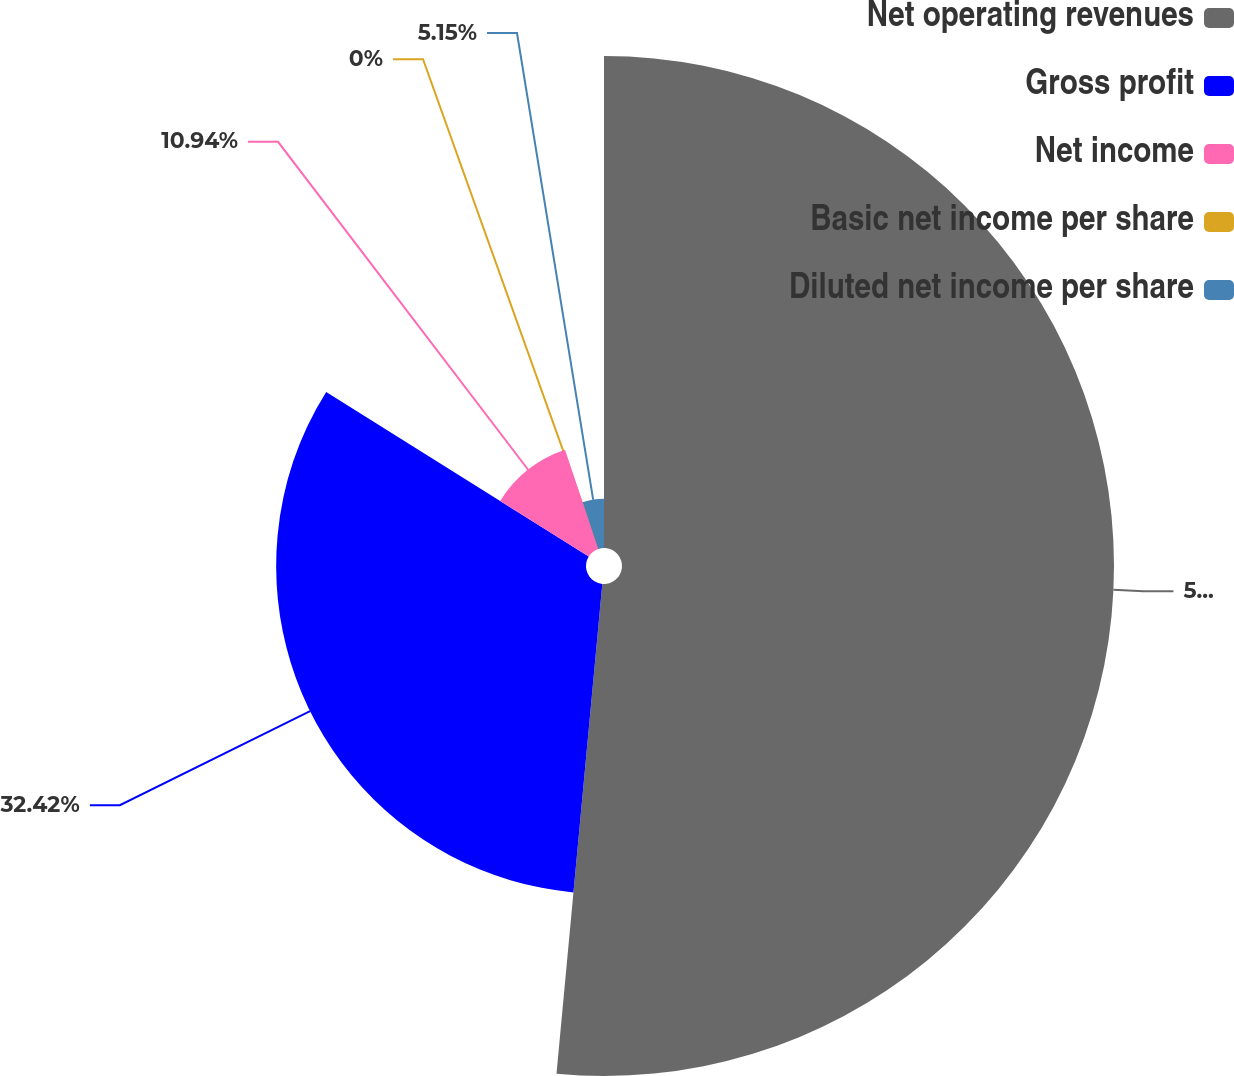<chart> <loc_0><loc_0><loc_500><loc_500><pie_chart><fcel>Net operating revenues<fcel>Gross profit<fcel>Net income<fcel>Basic net income per share<fcel>Diluted net income per share<nl><fcel>51.48%<fcel>32.42%<fcel>10.94%<fcel>0.0%<fcel>5.15%<nl></chart> 